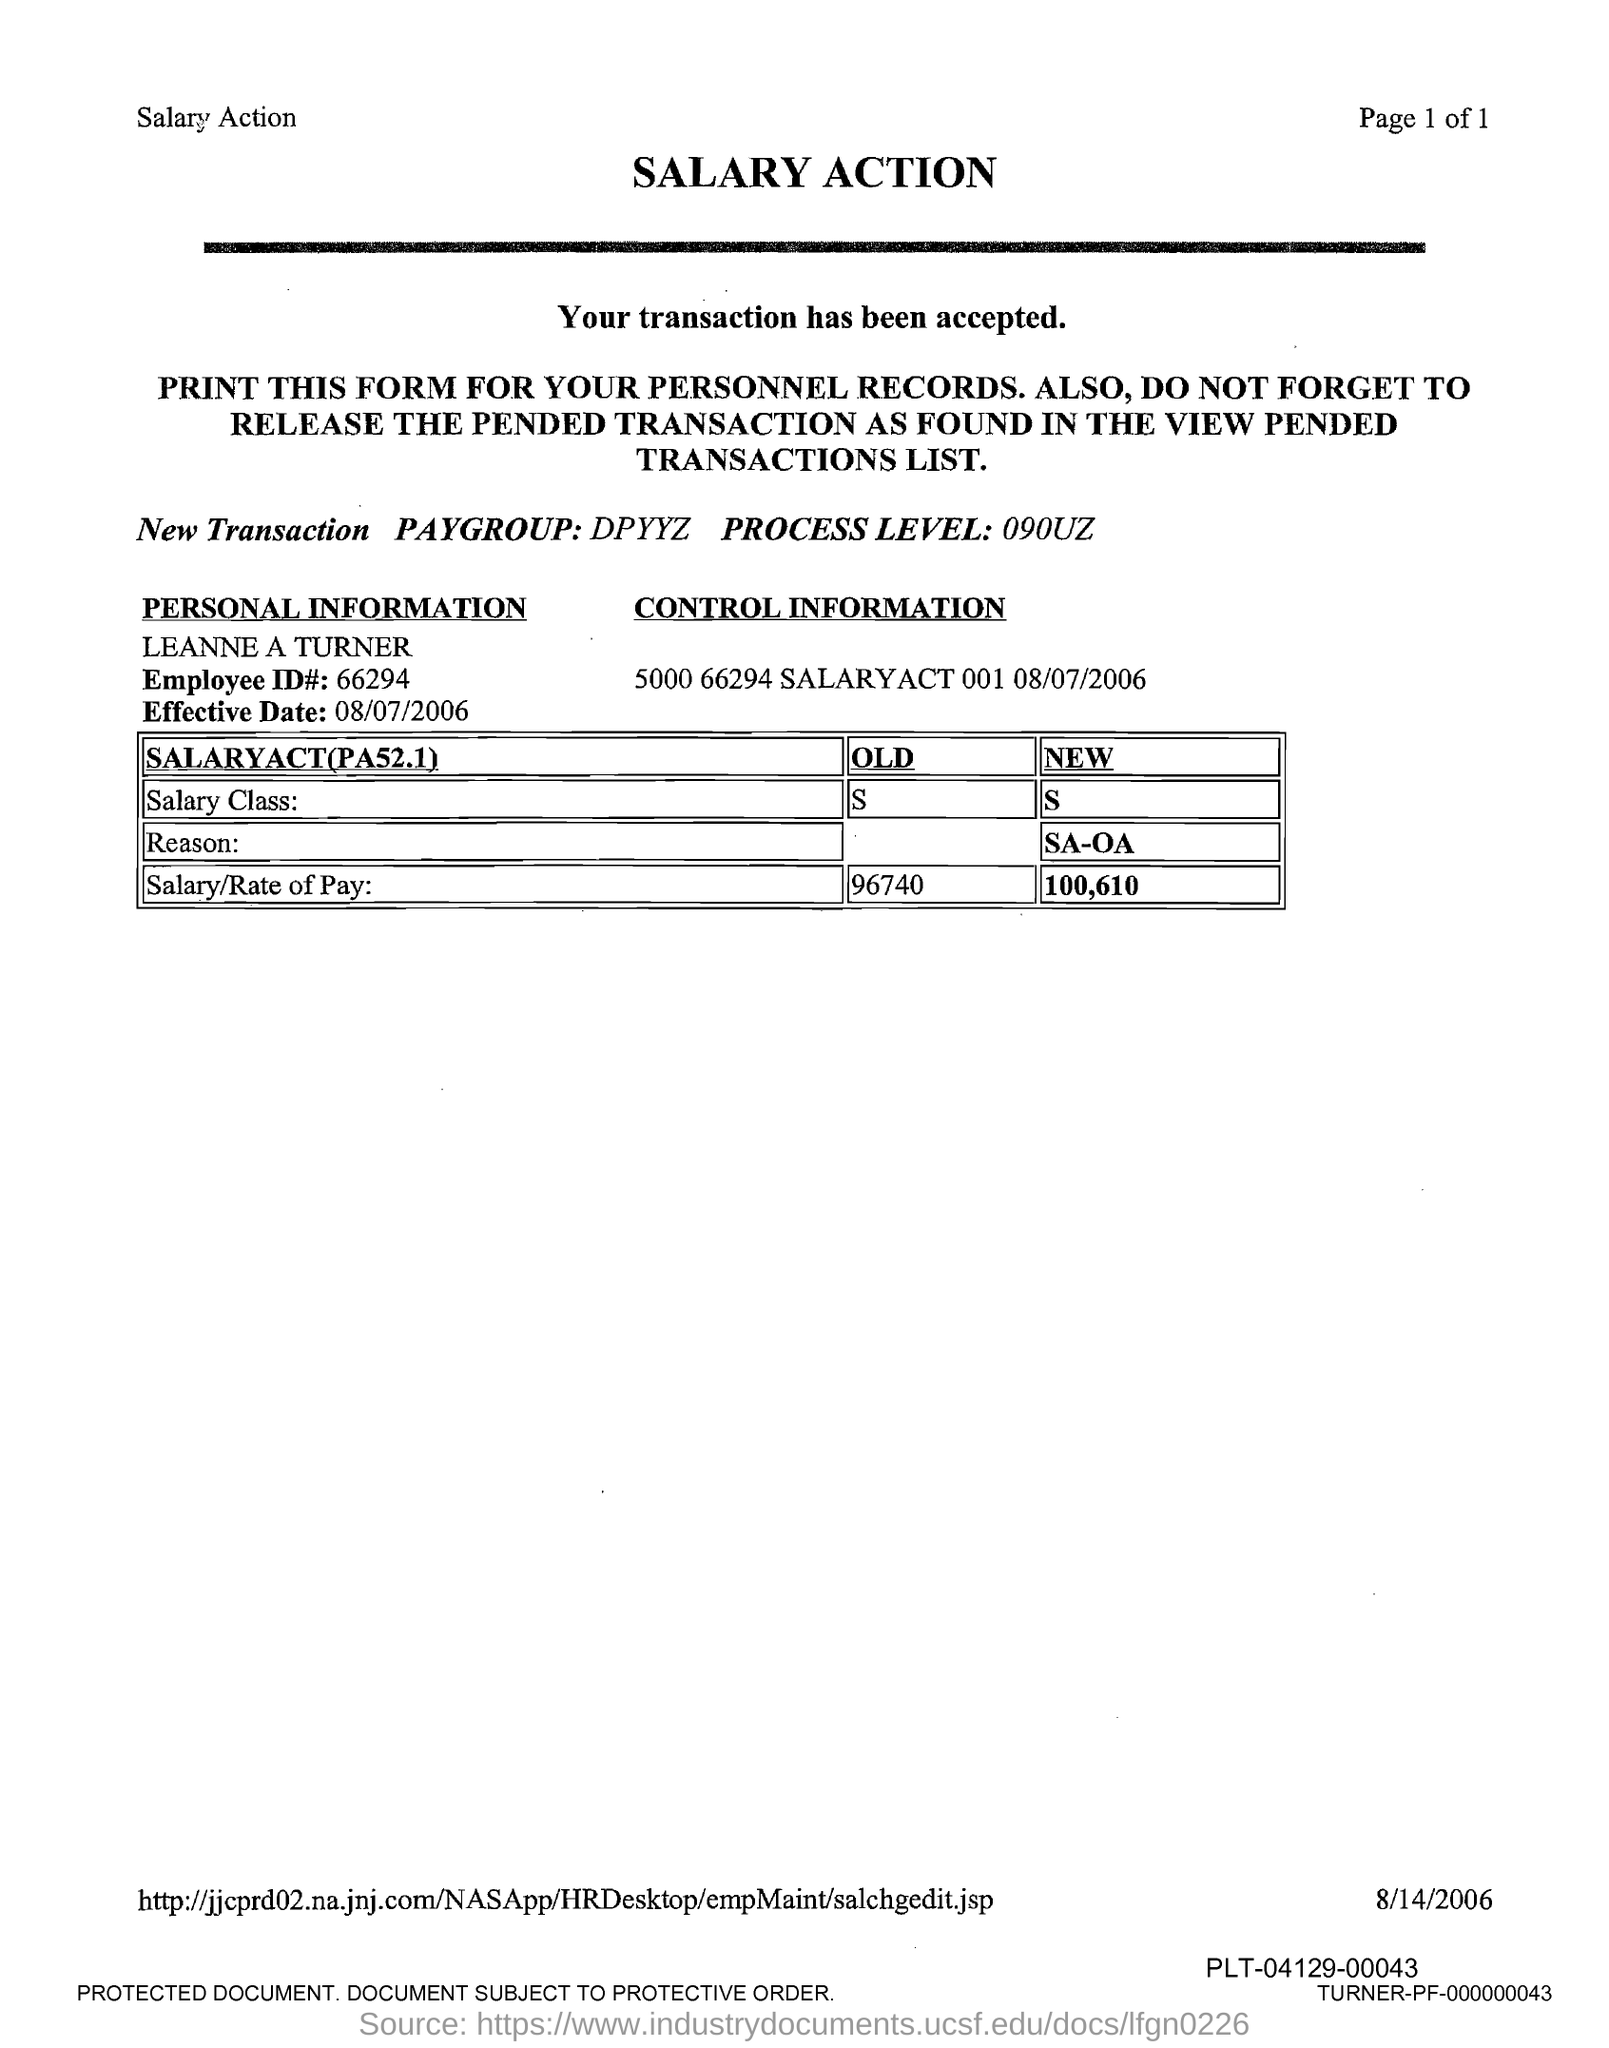What is the title of the document?
Offer a very short reply. Salary Action. What is the Employee id#?
Provide a succinct answer. 66294. 